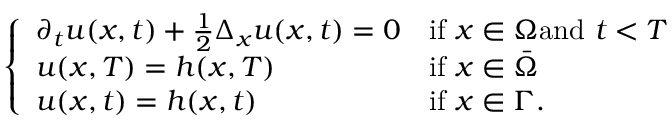<formula> <loc_0><loc_0><loc_500><loc_500>\left \{ \begin{array} { l l } { \partial _ { t } u ( x , t ) + { \frac { 1 } { 2 } } \Delta _ { x } u ( x , t ) = 0 } & { { i f } x \in \Omega { a n d } t < T } \\ { u ( x , T ) = h ( x , T ) } & { { i f } x \in { \bar { \Omega } } } \\ { u ( x , t ) = h ( x , t ) } & { { i f } x \in \Gamma . } \end{array}</formula> 